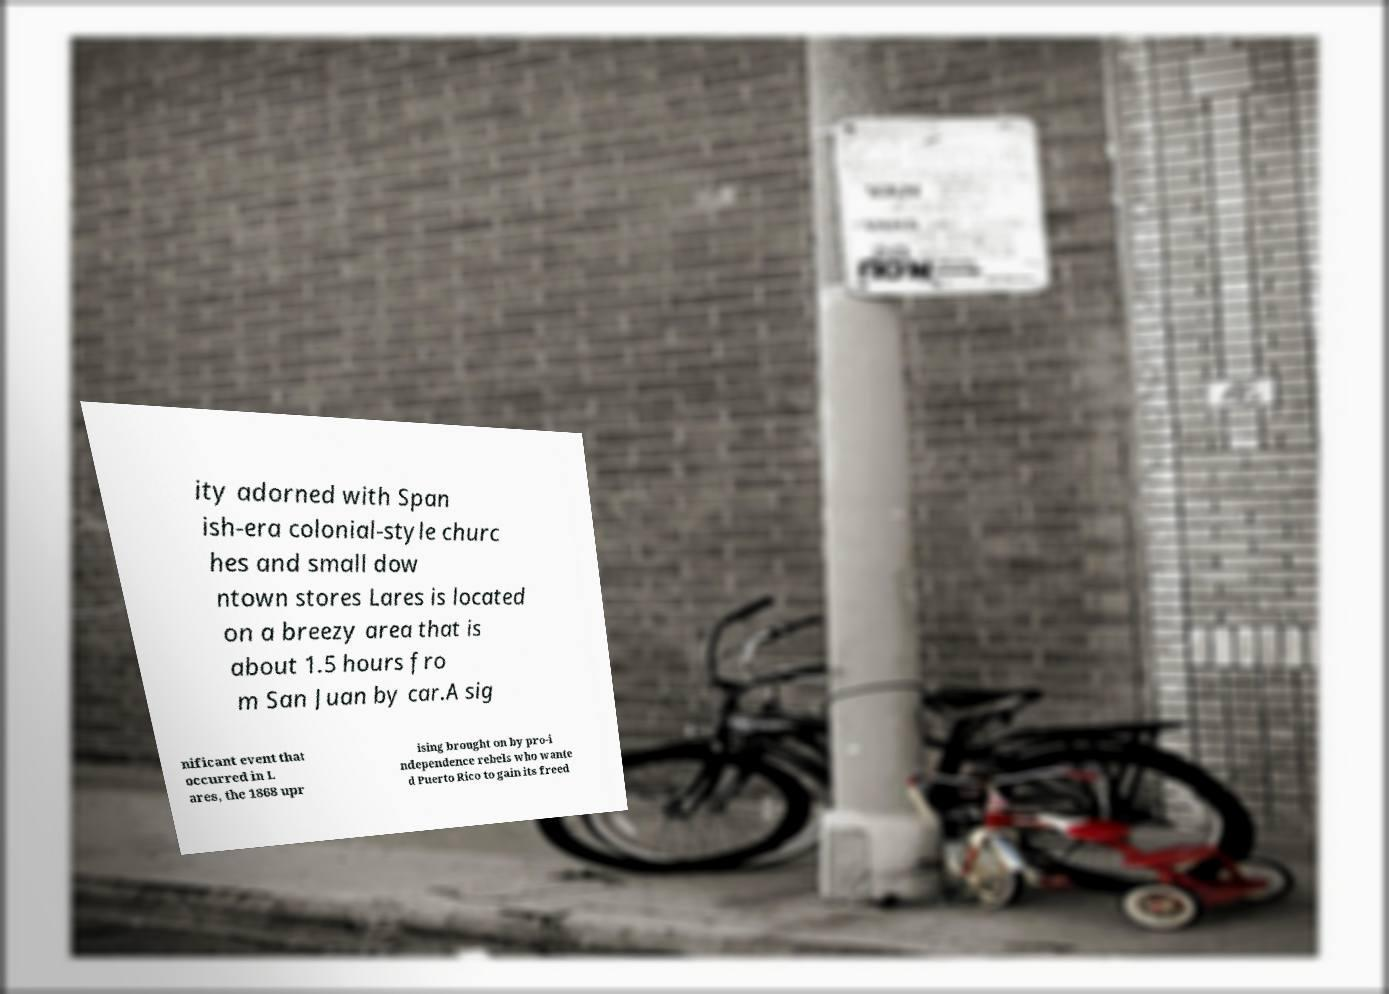Please identify and transcribe the text found in this image. ity adorned with Span ish-era colonial-style churc hes and small dow ntown stores Lares is located on a breezy area that is about 1.5 hours fro m San Juan by car.A sig nificant event that occurred in L ares, the 1868 upr ising brought on by pro-i ndependence rebels who wante d Puerto Rico to gain its freed 